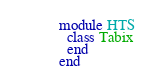Convert code to text. <code><loc_0><loc_0><loc_500><loc_500><_Crystal_>module HTS
  class Tabix
  end
end
</code> 